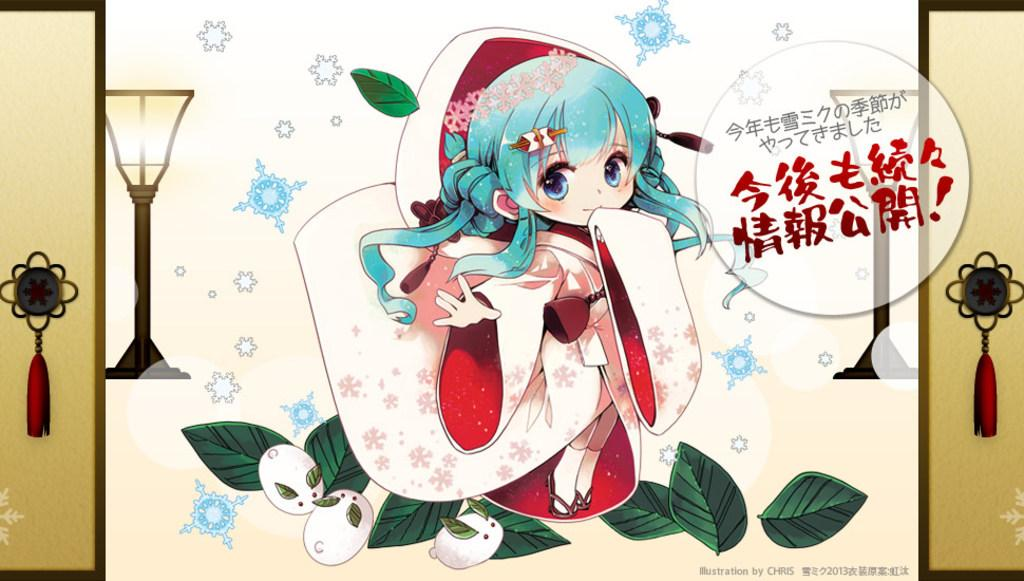What is the main subject of the animated image? The main subject of the animated image is a person with a dress. What type of natural elements can be seen in the image? Leaves are visible in the image. What type of lighting is present in the image? Lamps are present in the image. Is there any text included in the image? Yes, there is text written on the image. How many cards are being covered by the person's thumb in the image? There are no cards or thumbs present in the image. 